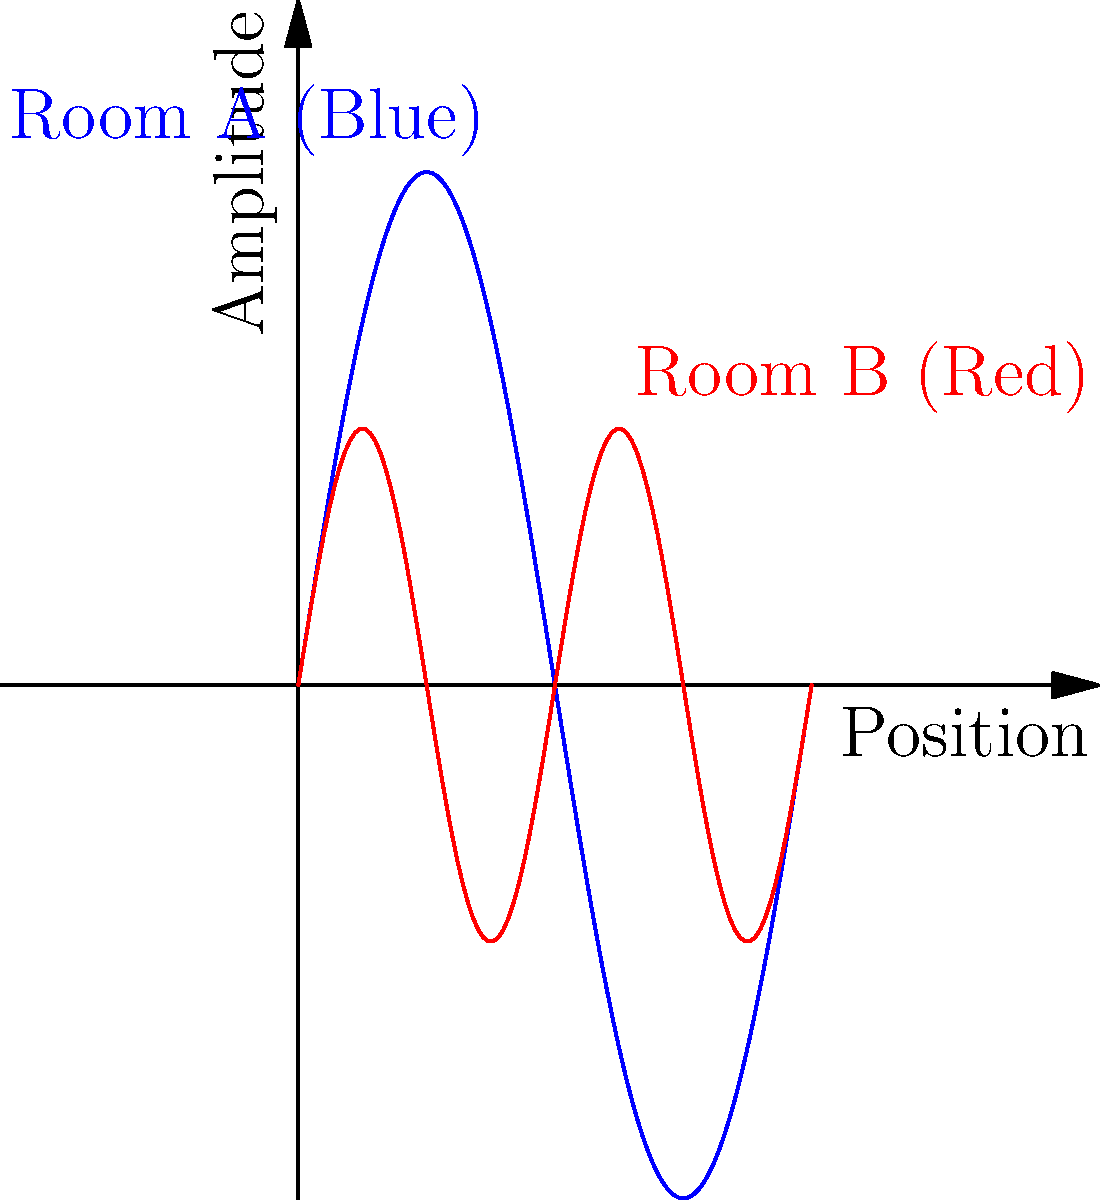In your bed and breakfast, you've noticed that two similarly sized rooms have different acoustic properties. The graph above represents sound wave patterns in these rooms. Based on the wave patterns shown, which room would be more suitable for a quiet reading area, and why? To determine which room is more suitable for a quiet reading area, we need to analyze the wave patterns:

1. Room A (Blue wave):
   - Has a lower frequency (fewer cycles in the given space)
   - Larger amplitude (higher peaks and lower troughs)

2. Room B (Red wave):
   - Has a higher frequency (more cycles in the given space)
   - Smaller amplitude (lower peaks and higher troughs)

Key considerations:

1. Frequency: Higher frequency sounds are generally perceived as "sharper" or "brighter," while lower frequency sounds are "deeper" or "fuller."

2. Amplitude: Larger amplitude corresponds to louder sounds, while smaller amplitude corresponds to quieter sounds.

3. Room acoustics: 
   - Room A might amplify lower frequency sounds more, potentially causing a "boomy" effect.
   - Room B might diffuse sound more effectively due to its higher frequency response, leading to less resonance.

4. Human hearing: Our ears are generally more sensitive to mid-range frequencies, which Room B's pattern more closely resembles.

Given these factors, Room B (represented by the red wave) would be more suitable for a quiet reading area because:
1. Its smaller amplitude suggests quieter overall sound levels.
2. The higher frequency pattern indicates better sound diffusion, reducing echoes and resonance.
3. It's less likely to amplify low-frequency background noises that could be distracting while reading.
Answer: Room B (red wave pattern) 